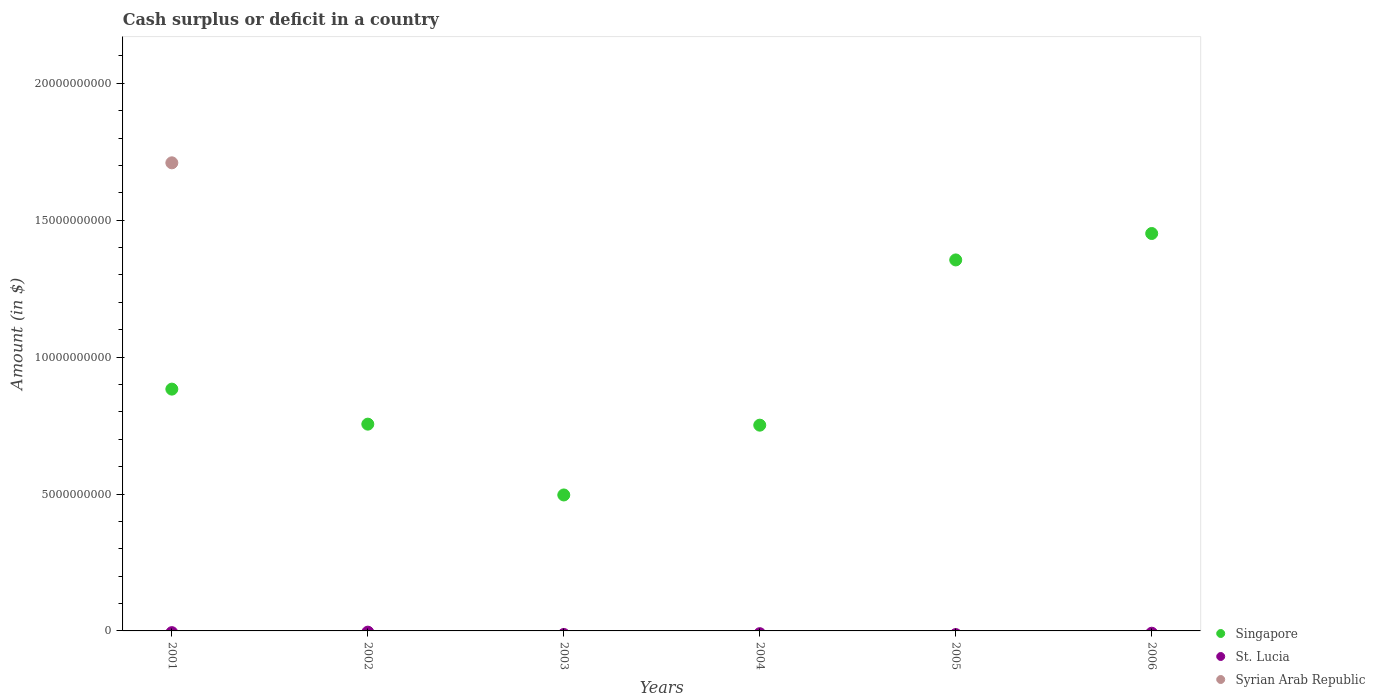Is the number of dotlines equal to the number of legend labels?
Provide a short and direct response. No. What is the amount of cash surplus or deficit in Syrian Arab Republic in 2001?
Give a very brief answer. 1.71e+1. Across all years, what is the maximum amount of cash surplus or deficit in Singapore?
Your answer should be compact. 1.45e+1. Across all years, what is the minimum amount of cash surplus or deficit in Syrian Arab Republic?
Offer a terse response. 0. What is the difference between the amount of cash surplus or deficit in Singapore in 2001 and that in 2004?
Keep it short and to the point. 1.32e+09. What is the difference between the amount of cash surplus or deficit in Syrian Arab Republic in 2006 and the amount of cash surplus or deficit in Singapore in 2005?
Your answer should be very brief. -1.35e+1. What is the average amount of cash surplus or deficit in Syrian Arab Republic per year?
Your answer should be compact. 2.85e+09. In the year 2001, what is the difference between the amount of cash surplus or deficit in Singapore and amount of cash surplus or deficit in Syrian Arab Republic?
Make the answer very short. -8.26e+09. In how many years, is the amount of cash surplus or deficit in Singapore greater than 12000000000 $?
Your response must be concise. 2. What is the ratio of the amount of cash surplus or deficit in Singapore in 2002 to that in 2003?
Keep it short and to the point. 1.52. Is the amount of cash surplus or deficit in Singapore in 2003 less than that in 2006?
Offer a terse response. Yes. What is the difference between the highest and the second highest amount of cash surplus or deficit in Singapore?
Give a very brief answer. 9.65e+08. What is the difference between the highest and the lowest amount of cash surplus or deficit in Singapore?
Offer a terse response. 9.55e+09. In how many years, is the amount of cash surplus or deficit in Syrian Arab Republic greater than the average amount of cash surplus or deficit in Syrian Arab Republic taken over all years?
Make the answer very short. 1. Is the amount of cash surplus or deficit in St. Lucia strictly greater than the amount of cash surplus or deficit in Syrian Arab Republic over the years?
Make the answer very short. No. How many dotlines are there?
Your answer should be very brief. 2. What is the difference between two consecutive major ticks on the Y-axis?
Your answer should be compact. 5.00e+09. Does the graph contain any zero values?
Your answer should be compact. Yes. Does the graph contain grids?
Make the answer very short. No. How many legend labels are there?
Offer a very short reply. 3. What is the title of the graph?
Give a very brief answer. Cash surplus or deficit in a country. Does "Burundi" appear as one of the legend labels in the graph?
Your response must be concise. No. What is the label or title of the X-axis?
Offer a very short reply. Years. What is the label or title of the Y-axis?
Make the answer very short. Amount (in $). What is the Amount (in $) in Singapore in 2001?
Keep it short and to the point. 8.83e+09. What is the Amount (in $) of Syrian Arab Republic in 2001?
Your response must be concise. 1.71e+1. What is the Amount (in $) of Singapore in 2002?
Offer a terse response. 7.55e+09. What is the Amount (in $) in Singapore in 2003?
Offer a very short reply. 4.96e+09. What is the Amount (in $) in St. Lucia in 2003?
Make the answer very short. 0. What is the Amount (in $) in Singapore in 2004?
Keep it short and to the point. 7.51e+09. What is the Amount (in $) in St. Lucia in 2004?
Ensure brevity in your answer.  0. What is the Amount (in $) in Singapore in 2005?
Your response must be concise. 1.35e+1. What is the Amount (in $) in Syrian Arab Republic in 2005?
Provide a succinct answer. 0. What is the Amount (in $) in Singapore in 2006?
Provide a short and direct response. 1.45e+1. What is the Amount (in $) in Syrian Arab Republic in 2006?
Provide a short and direct response. 0. Across all years, what is the maximum Amount (in $) of Singapore?
Your answer should be compact. 1.45e+1. Across all years, what is the maximum Amount (in $) of Syrian Arab Republic?
Make the answer very short. 1.71e+1. Across all years, what is the minimum Amount (in $) of Singapore?
Provide a succinct answer. 4.96e+09. What is the total Amount (in $) of Singapore in the graph?
Your answer should be very brief. 5.69e+1. What is the total Amount (in $) in St. Lucia in the graph?
Make the answer very short. 0. What is the total Amount (in $) in Syrian Arab Republic in the graph?
Offer a very short reply. 1.71e+1. What is the difference between the Amount (in $) of Singapore in 2001 and that in 2002?
Make the answer very short. 1.28e+09. What is the difference between the Amount (in $) in Singapore in 2001 and that in 2003?
Provide a succinct answer. 3.86e+09. What is the difference between the Amount (in $) of Singapore in 2001 and that in 2004?
Keep it short and to the point. 1.32e+09. What is the difference between the Amount (in $) in Singapore in 2001 and that in 2005?
Ensure brevity in your answer.  -4.72e+09. What is the difference between the Amount (in $) of Singapore in 2001 and that in 2006?
Offer a terse response. -5.68e+09. What is the difference between the Amount (in $) of Singapore in 2002 and that in 2003?
Provide a succinct answer. 2.59e+09. What is the difference between the Amount (in $) in Singapore in 2002 and that in 2004?
Your response must be concise. 3.70e+07. What is the difference between the Amount (in $) of Singapore in 2002 and that in 2005?
Offer a very short reply. -6.00e+09. What is the difference between the Amount (in $) in Singapore in 2002 and that in 2006?
Ensure brevity in your answer.  -6.96e+09. What is the difference between the Amount (in $) of Singapore in 2003 and that in 2004?
Your response must be concise. -2.55e+09. What is the difference between the Amount (in $) in Singapore in 2003 and that in 2005?
Ensure brevity in your answer.  -8.58e+09. What is the difference between the Amount (in $) of Singapore in 2003 and that in 2006?
Your answer should be compact. -9.55e+09. What is the difference between the Amount (in $) in Singapore in 2004 and that in 2005?
Your answer should be very brief. -6.03e+09. What is the difference between the Amount (in $) of Singapore in 2004 and that in 2006?
Your answer should be very brief. -7.00e+09. What is the difference between the Amount (in $) of Singapore in 2005 and that in 2006?
Give a very brief answer. -9.65e+08. What is the average Amount (in $) of Singapore per year?
Give a very brief answer. 9.49e+09. What is the average Amount (in $) of Syrian Arab Republic per year?
Provide a short and direct response. 2.85e+09. In the year 2001, what is the difference between the Amount (in $) of Singapore and Amount (in $) of Syrian Arab Republic?
Give a very brief answer. -8.26e+09. What is the ratio of the Amount (in $) of Singapore in 2001 to that in 2002?
Make the answer very short. 1.17. What is the ratio of the Amount (in $) of Singapore in 2001 to that in 2003?
Give a very brief answer. 1.78. What is the ratio of the Amount (in $) of Singapore in 2001 to that in 2004?
Give a very brief answer. 1.18. What is the ratio of the Amount (in $) in Singapore in 2001 to that in 2005?
Offer a very short reply. 0.65. What is the ratio of the Amount (in $) of Singapore in 2001 to that in 2006?
Offer a very short reply. 0.61. What is the ratio of the Amount (in $) of Singapore in 2002 to that in 2003?
Provide a succinct answer. 1.52. What is the ratio of the Amount (in $) of Singapore in 2002 to that in 2005?
Offer a very short reply. 0.56. What is the ratio of the Amount (in $) of Singapore in 2002 to that in 2006?
Offer a terse response. 0.52. What is the ratio of the Amount (in $) of Singapore in 2003 to that in 2004?
Offer a very short reply. 0.66. What is the ratio of the Amount (in $) of Singapore in 2003 to that in 2005?
Make the answer very short. 0.37. What is the ratio of the Amount (in $) in Singapore in 2003 to that in 2006?
Provide a short and direct response. 0.34. What is the ratio of the Amount (in $) in Singapore in 2004 to that in 2005?
Make the answer very short. 0.55. What is the ratio of the Amount (in $) in Singapore in 2004 to that in 2006?
Your response must be concise. 0.52. What is the ratio of the Amount (in $) of Singapore in 2005 to that in 2006?
Keep it short and to the point. 0.93. What is the difference between the highest and the second highest Amount (in $) in Singapore?
Your answer should be compact. 9.65e+08. What is the difference between the highest and the lowest Amount (in $) of Singapore?
Give a very brief answer. 9.55e+09. What is the difference between the highest and the lowest Amount (in $) of Syrian Arab Republic?
Your answer should be compact. 1.71e+1. 